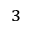Convert formula to latex. <formula><loc_0><loc_0><loc_500><loc_500>^ { 3 }</formula> 